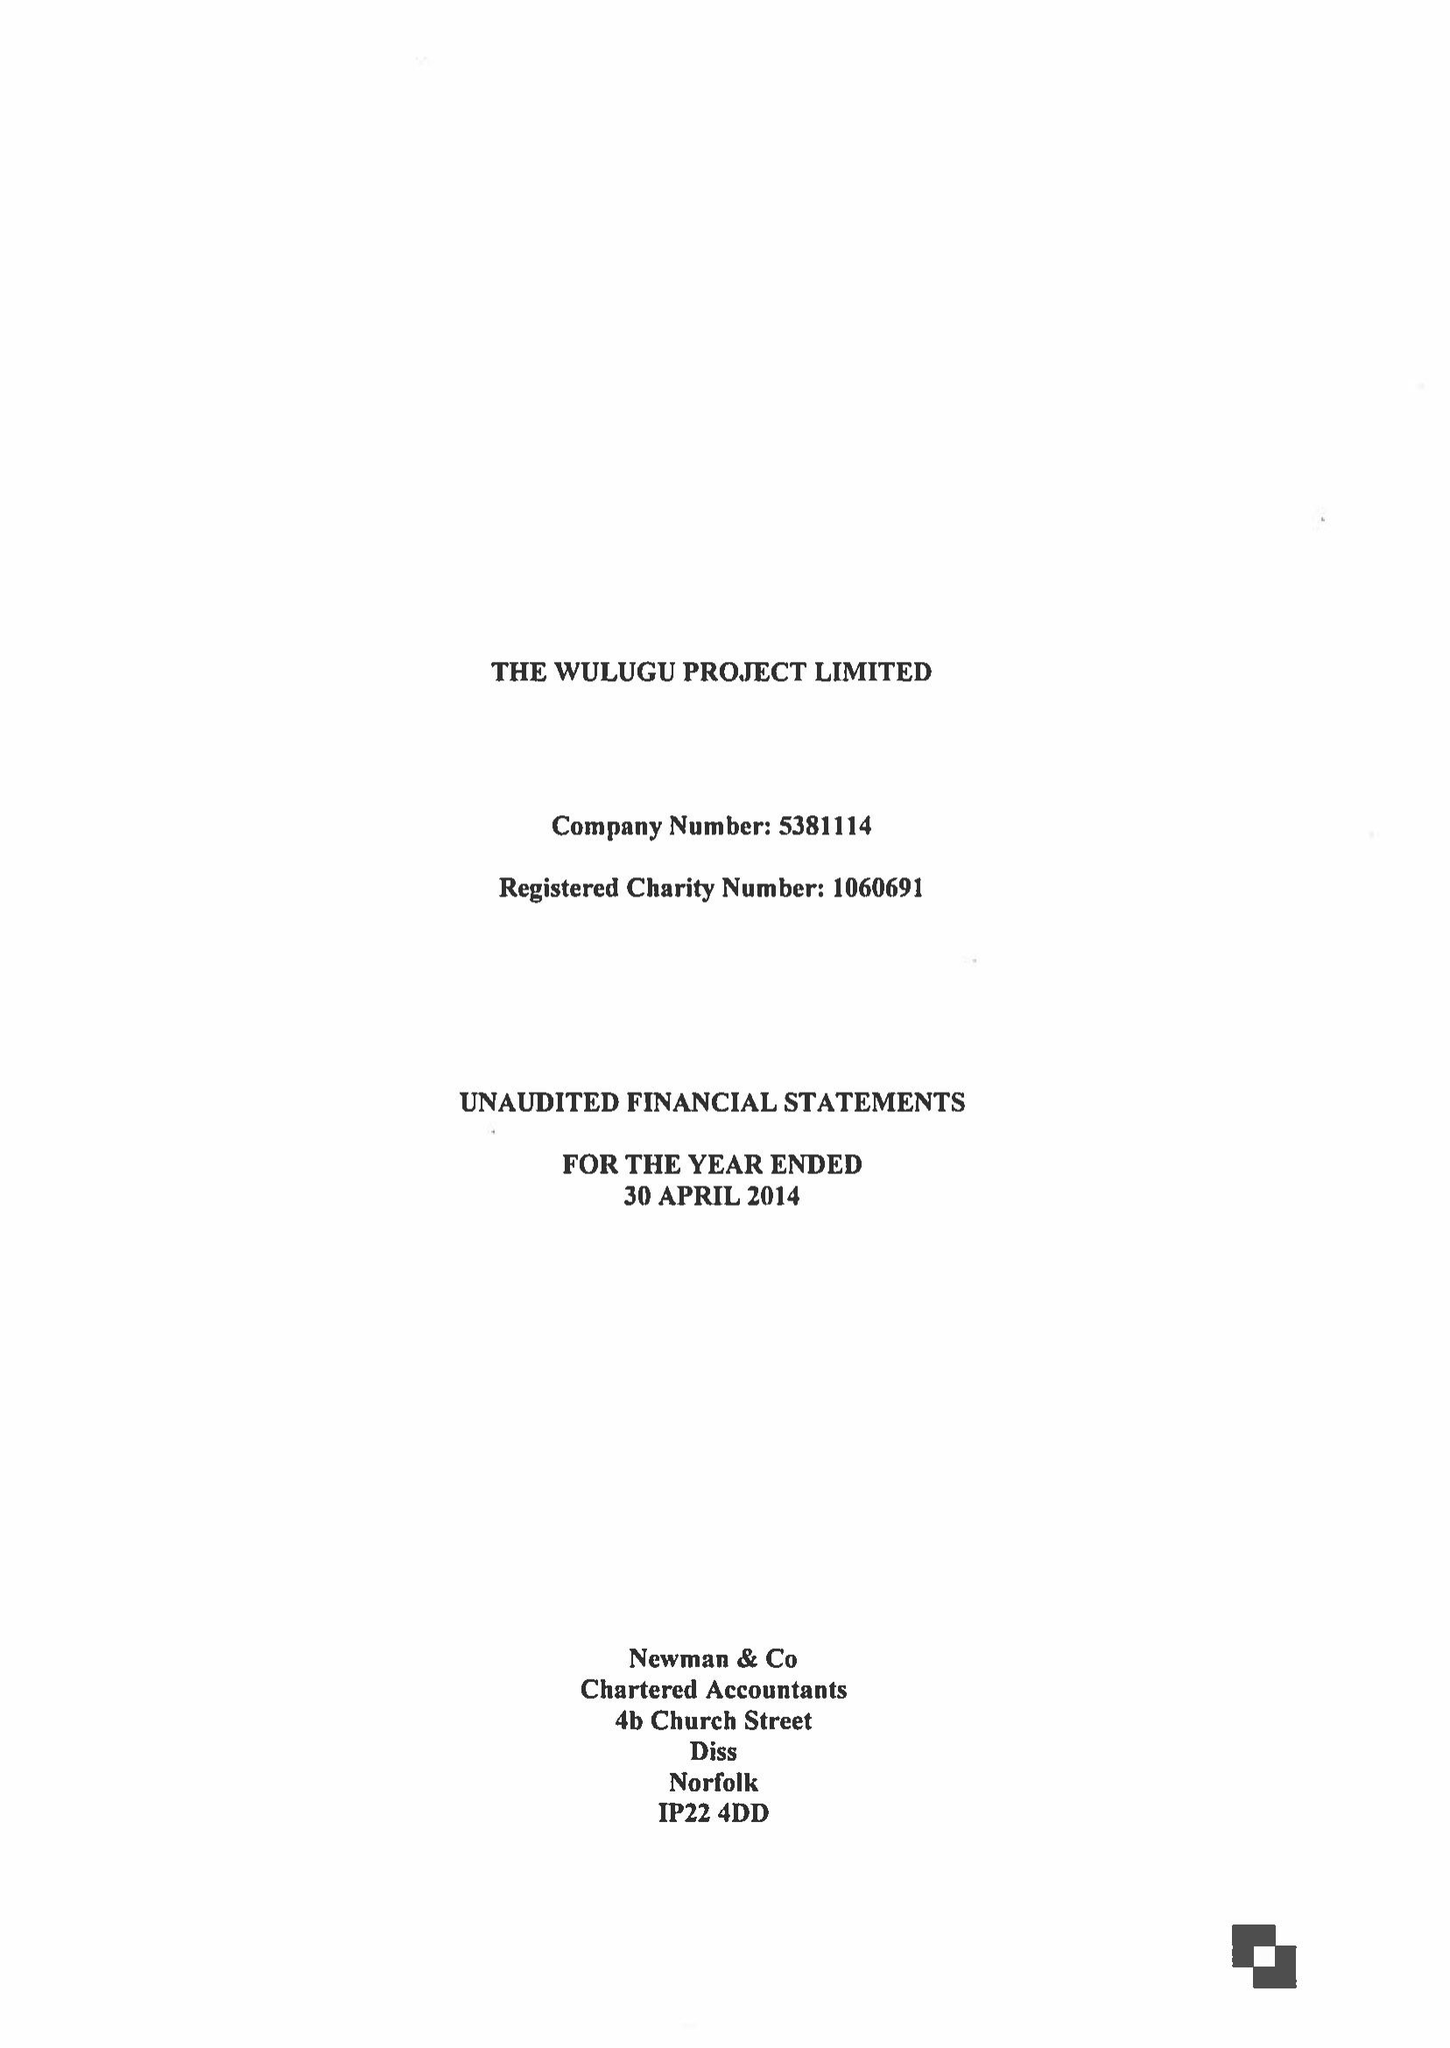What is the value for the address__street_line?
Answer the question using a single word or phrase. CHURCH FARM 